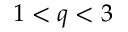Convert formula to latex. <formula><loc_0><loc_0><loc_500><loc_500>1 < q < 3</formula> 